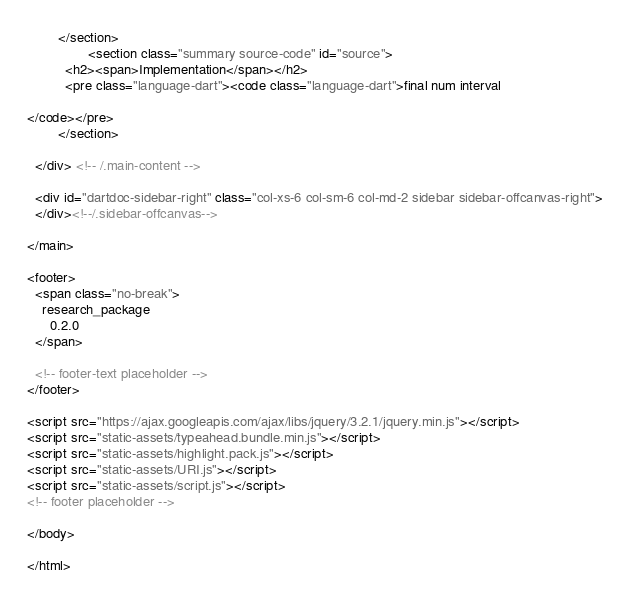Convert code to text. <code><loc_0><loc_0><loc_500><loc_500><_HTML_>        </section>
                <section class="summary source-code" id="source">
          <h2><span>Implementation</span></h2>
          <pre class="language-dart"><code class="language-dart">final num interval

</code></pre>
        </section>

  </div> <!-- /.main-content -->

  <div id="dartdoc-sidebar-right" class="col-xs-6 col-sm-6 col-md-2 sidebar sidebar-offcanvas-right">
  </div><!--/.sidebar-offcanvas-->

</main>

<footer>
  <span class="no-break">
    research_package
      0.2.0
  </span>

  <!-- footer-text placeholder -->
</footer>

<script src="https://ajax.googleapis.com/ajax/libs/jquery/3.2.1/jquery.min.js"></script>
<script src="static-assets/typeahead.bundle.min.js"></script>
<script src="static-assets/highlight.pack.js"></script>
<script src="static-assets/URI.js"></script>
<script src="static-assets/script.js"></script>
<!-- footer placeholder -->

</body>

</html>
</code> 